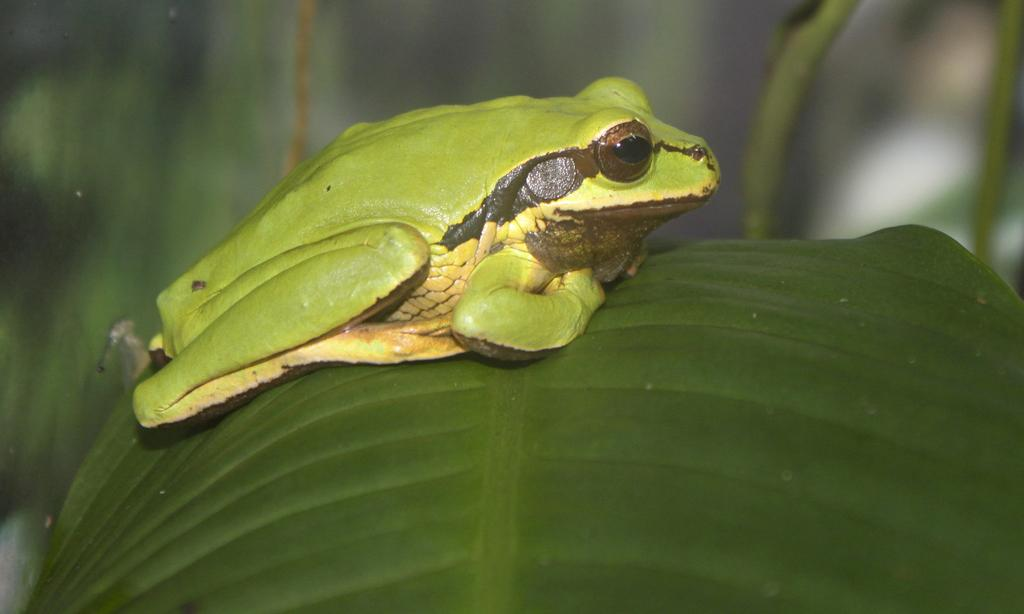What is the primary color of the leaf in the image? The primary color of the leaf in the image is green. What is sitting on the leaf in the image? There is a green frog on the leaf in the image. How would you describe the overall clarity of the image? The image is slightly blurry in the background. What type of trousers is the frog wearing in the image? There are no trousers present in the image, as frogs do not wear clothing. 